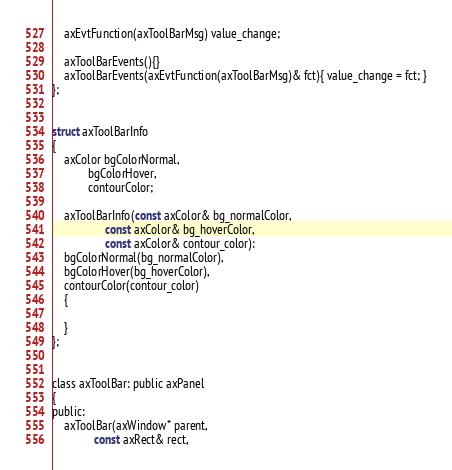Convert code to text. <code><loc_0><loc_0><loc_500><loc_500><_C_>    axEvtFunction(axToolBarMsg) value_change;
    
    axToolBarEvents(){}
    axToolBarEvents(axEvtFunction(axToolBarMsg)& fct){ value_change = fct; }
};


struct axToolBarInfo
{
    axColor bgColorNormal,
            bgColorHover,
            contourColor;

    axToolBarInfo(const axColor& bg_normalColor,
                  const axColor& bg_hoverColor,
                  const axColor& contour_color):
    bgColorNormal(bg_normalColor),
    bgColorHover(bg_hoverColor),
    contourColor(contour_color)
    {
        
    }
};


class axToolBar: public axPanel
{
public:
    axToolBar(axWindow* parent,
              const axRect& rect,</code> 